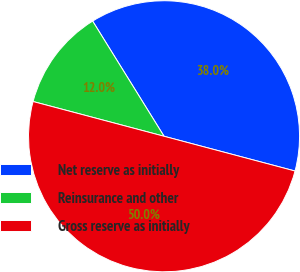Convert chart to OTSL. <chart><loc_0><loc_0><loc_500><loc_500><pie_chart><fcel>Net reserve as initially<fcel>Reinsurance and other<fcel>Gross reserve as initially<nl><fcel>37.96%<fcel>12.04%<fcel>50.0%<nl></chart> 